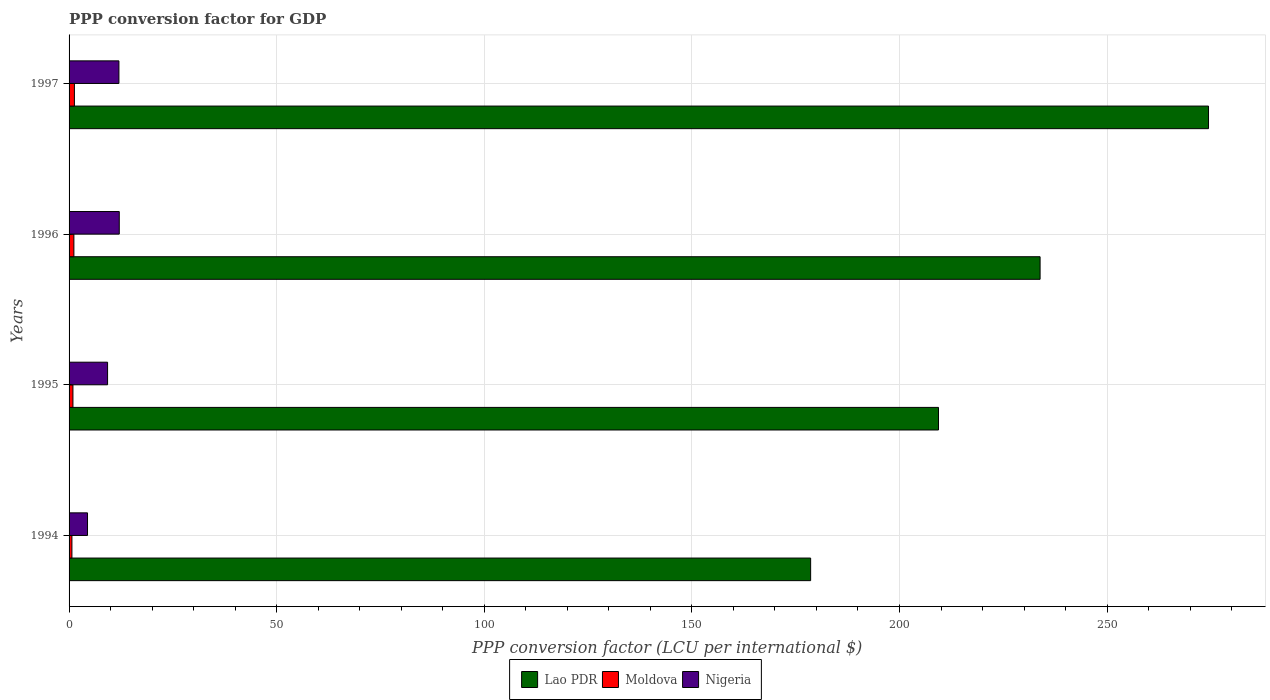How many different coloured bars are there?
Ensure brevity in your answer.  3. How many groups of bars are there?
Offer a terse response. 4. How many bars are there on the 2nd tick from the bottom?
Give a very brief answer. 3. What is the PPP conversion factor for GDP in Nigeria in 1994?
Ensure brevity in your answer.  4.44. Across all years, what is the maximum PPP conversion factor for GDP in Moldova?
Ensure brevity in your answer.  1.28. Across all years, what is the minimum PPP conversion factor for GDP in Lao PDR?
Provide a succinct answer. 178.6. In which year was the PPP conversion factor for GDP in Lao PDR maximum?
Offer a terse response. 1997. What is the total PPP conversion factor for GDP in Moldova in the graph?
Ensure brevity in your answer.  4.06. What is the difference between the PPP conversion factor for GDP in Moldova in 1994 and that in 1995?
Keep it short and to the point. -0.25. What is the difference between the PPP conversion factor for GDP in Nigeria in 1994 and the PPP conversion factor for GDP in Lao PDR in 1995?
Make the answer very short. -204.95. What is the average PPP conversion factor for GDP in Lao PDR per year?
Provide a succinct answer. 224.07. In the year 1994, what is the difference between the PPP conversion factor for GDP in Lao PDR and PPP conversion factor for GDP in Moldova?
Your response must be concise. 177.91. What is the ratio of the PPP conversion factor for GDP in Lao PDR in 1995 to that in 1997?
Your answer should be compact. 0.76. Is the PPP conversion factor for GDP in Nigeria in 1994 less than that in 1997?
Ensure brevity in your answer.  Yes. Is the difference between the PPP conversion factor for GDP in Lao PDR in 1996 and 1997 greater than the difference between the PPP conversion factor for GDP in Moldova in 1996 and 1997?
Make the answer very short. No. What is the difference between the highest and the second highest PPP conversion factor for GDP in Moldova?
Offer a terse response. 0.12. What is the difference between the highest and the lowest PPP conversion factor for GDP in Moldova?
Your answer should be compact. 0.6. What does the 2nd bar from the top in 1994 represents?
Keep it short and to the point. Moldova. What does the 2nd bar from the bottom in 1996 represents?
Your response must be concise. Moldova. Are all the bars in the graph horizontal?
Make the answer very short. Yes. What is the difference between two consecutive major ticks on the X-axis?
Ensure brevity in your answer.  50. Does the graph contain grids?
Keep it short and to the point. Yes. How many legend labels are there?
Provide a short and direct response. 3. How are the legend labels stacked?
Offer a very short reply. Horizontal. What is the title of the graph?
Provide a short and direct response. PPP conversion factor for GDP. Does "Palau" appear as one of the legend labels in the graph?
Your answer should be very brief. No. What is the label or title of the X-axis?
Your answer should be compact. PPP conversion factor (LCU per international $). What is the label or title of the Y-axis?
Your response must be concise. Years. What is the PPP conversion factor (LCU per international $) of Lao PDR in 1994?
Your answer should be compact. 178.6. What is the PPP conversion factor (LCU per international $) of Moldova in 1994?
Offer a terse response. 0.69. What is the PPP conversion factor (LCU per international $) in Nigeria in 1994?
Provide a short and direct response. 4.44. What is the PPP conversion factor (LCU per international $) of Lao PDR in 1995?
Provide a short and direct response. 209.39. What is the PPP conversion factor (LCU per international $) in Moldova in 1995?
Offer a terse response. 0.93. What is the PPP conversion factor (LCU per international $) of Nigeria in 1995?
Offer a very short reply. 9.27. What is the PPP conversion factor (LCU per international $) of Lao PDR in 1996?
Keep it short and to the point. 233.86. What is the PPP conversion factor (LCU per international $) in Moldova in 1996?
Keep it short and to the point. 1.16. What is the PPP conversion factor (LCU per international $) in Nigeria in 1996?
Give a very brief answer. 12.09. What is the PPP conversion factor (LCU per international $) in Lao PDR in 1997?
Offer a very short reply. 274.42. What is the PPP conversion factor (LCU per international $) in Moldova in 1997?
Your answer should be compact. 1.28. What is the PPP conversion factor (LCU per international $) of Nigeria in 1997?
Keep it short and to the point. 12.01. Across all years, what is the maximum PPP conversion factor (LCU per international $) of Lao PDR?
Provide a succinct answer. 274.42. Across all years, what is the maximum PPP conversion factor (LCU per international $) in Moldova?
Give a very brief answer. 1.28. Across all years, what is the maximum PPP conversion factor (LCU per international $) in Nigeria?
Provide a succinct answer. 12.09. Across all years, what is the minimum PPP conversion factor (LCU per international $) in Lao PDR?
Your response must be concise. 178.6. Across all years, what is the minimum PPP conversion factor (LCU per international $) in Moldova?
Ensure brevity in your answer.  0.69. Across all years, what is the minimum PPP conversion factor (LCU per international $) in Nigeria?
Offer a very short reply. 4.44. What is the total PPP conversion factor (LCU per international $) of Lao PDR in the graph?
Your answer should be compact. 896.27. What is the total PPP conversion factor (LCU per international $) of Moldova in the graph?
Offer a terse response. 4.06. What is the total PPP conversion factor (LCU per international $) of Nigeria in the graph?
Provide a short and direct response. 37.81. What is the difference between the PPP conversion factor (LCU per international $) in Lao PDR in 1994 and that in 1995?
Provide a short and direct response. -30.79. What is the difference between the PPP conversion factor (LCU per international $) of Moldova in 1994 and that in 1995?
Your answer should be compact. -0.25. What is the difference between the PPP conversion factor (LCU per international $) in Nigeria in 1994 and that in 1995?
Your response must be concise. -4.83. What is the difference between the PPP conversion factor (LCU per international $) of Lao PDR in 1994 and that in 1996?
Provide a succinct answer. -55.26. What is the difference between the PPP conversion factor (LCU per international $) of Moldova in 1994 and that in 1996?
Keep it short and to the point. -0.48. What is the difference between the PPP conversion factor (LCU per international $) of Nigeria in 1994 and that in 1996?
Keep it short and to the point. -7.65. What is the difference between the PPP conversion factor (LCU per international $) in Lao PDR in 1994 and that in 1997?
Give a very brief answer. -95.82. What is the difference between the PPP conversion factor (LCU per international $) of Moldova in 1994 and that in 1997?
Make the answer very short. -0.6. What is the difference between the PPP conversion factor (LCU per international $) of Nigeria in 1994 and that in 1997?
Make the answer very short. -7.56. What is the difference between the PPP conversion factor (LCU per international $) of Lao PDR in 1995 and that in 1996?
Give a very brief answer. -24.47. What is the difference between the PPP conversion factor (LCU per international $) of Moldova in 1995 and that in 1996?
Provide a short and direct response. -0.23. What is the difference between the PPP conversion factor (LCU per international $) in Nigeria in 1995 and that in 1996?
Offer a very short reply. -2.81. What is the difference between the PPP conversion factor (LCU per international $) of Lao PDR in 1995 and that in 1997?
Your response must be concise. -65.03. What is the difference between the PPP conversion factor (LCU per international $) of Moldova in 1995 and that in 1997?
Your answer should be very brief. -0.35. What is the difference between the PPP conversion factor (LCU per international $) of Nigeria in 1995 and that in 1997?
Offer a terse response. -2.73. What is the difference between the PPP conversion factor (LCU per international $) of Lao PDR in 1996 and that in 1997?
Your answer should be compact. -40.56. What is the difference between the PPP conversion factor (LCU per international $) in Moldova in 1996 and that in 1997?
Ensure brevity in your answer.  -0.12. What is the difference between the PPP conversion factor (LCU per international $) of Nigeria in 1996 and that in 1997?
Keep it short and to the point. 0.08. What is the difference between the PPP conversion factor (LCU per international $) in Lao PDR in 1994 and the PPP conversion factor (LCU per international $) in Moldova in 1995?
Provide a short and direct response. 177.67. What is the difference between the PPP conversion factor (LCU per international $) in Lao PDR in 1994 and the PPP conversion factor (LCU per international $) in Nigeria in 1995?
Your response must be concise. 169.33. What is the difference between the PPP conversion factor (LCU per international $) in Moldova in 1994 and the PPP conversion factor (LCU per international $) in Nigeria in 1995?
Ensure brevity in your answer.  -8.59. What is the difference between the PPP conversion factor (LCU per international $) of Lao PDR in 1994 and the PPP conversion factor (LCU per international $) of Moldova in 1996?
Give a very brief answer. 177.44. What is the difference between the PPP conversion factor (LCU per international $) of Lao PDR in 1994 and the PPP conversion factor (LCU per international $) of Nigeria in 1996?
Provide a short and direct response. 166.51. What is the difference between the PPP conversion factor (LCU per international $) of Moldova in 1994 and the PPP conversion factor (LCU per international $) of Nigeria in 1996?
Provide a short and direct response. -11.4. What is the difference between the PPP conversion factor (LCU per international $) of Lao PDR in 1994 and the PPP conversion factor (LCU per international $) of Moldova in 1997?
Ensure brevity in your answer.  177.31. What is the difference between the PPP conversion factor (LCU per international $) in Lao PDR in 1994 and the PPP conversion factor (LCU per international $) in Nigeria in 1997?
Provide a short and direct response. 166.59. What is the difference between the PPP conversion factor (LCU per international $) in Moldova in 1994 and the PPP conversion factor (LCU per international $) in Nigeria in 1997?
Ensure brevity in your answer.  -11.32. What is the difference between the PPP conversion factor (LCU per international $) of Lao PDR in 1995 and the PPP conversion factor (LCU per international $) of Moldova in 1996?
Give a very brief answer. 208.23. What is the difference between the PPP conversion factor (LCU per international $) in Lao PDR in 1995 and the PPP conversion factor (LCU per international $) in Nigeria in 1996?
Your answer should be very brief. 197.3. What is the difference between the PPP conversion factor (LCU per international $) in Moldova in 1995 and the PPP conversion factor (LCU per international $) in Nigeria in 1996?
Your answer should be very brief. -11.16. What is the difference between the PPP conversion factor (LCU per international $) in Lao PDR in 1995 and the PPP conversion factor (LCU per international $) in Moldova in 1997?
Make the answer very short. 208.11. What is the difference between the PPP conversion factor (LCU per international $) of Lao PDR in 1995 and the PPP conversion factor (LCU per international $) of Nigeria in 1997?
Provide a succinct answer. 197.38. What is the difference between the PPP conversion factor (LCU per international $) of Moldova in 1995 and the PPP conversion factor (LCU per international $) of Nigeria in 1997?
Ensure brevity in your answer.  -11.07. What is the difference between the PPP conversion factor (LCU per international $) in Lao PDR in 1996 and the PPP conversion factor (LCU per international $) in Moldova in 1997?
Offer a very short reply. 232.58. What is the difference between the PPP conversion factor (LCU per international $) of Lao PDR in 1996 and the PPP conversion factor (LCU per international $) of Nigeria in 1997?
Offer a terse response. 221.85. What is the difference between the PPP conversion factor (LCU per international $) in Moldova in 1996 and the PPP conversion factor (LCU per international $) in Nigeria in 1997?
Provide a succinct answer. -10.84. What is the average PPP conversion factor (LCU per international $) of Lao PDR per year?
Offer a very short reply. 224.07. What is the average PPP conversion factor (LCU per international $) of Moldova per year?
Make the answer very short. 1.02. What is the average PPP conversion factor (LCU per international $) in Nigeria per year?
Provide a succinct answer. 9.45. In the year 1994, what is the difference between the PPP conversion factor (LCU per international $) of Lao PDR and PPP conversion factor (LCU per international $) of Moldova?
Ensure brevity in your answer.  177.91. In the year 1994, what is the difference between the PPP conversion factor (LCU per international $) in Lao PDR and PPP conversion factor (LCU per international $) in Nigeria?
Ensure brevity in your answer.  174.16. In the year 1994, what is the difference between the PPP conversion factor (LCU per international $) in Moldova and PPP conversion factor (LCU per international $) in Nigeria?
Provide a succinct answer. -3.76. In the year 1995, what is the difference between the PPP conversion factor (LCU per international $) of Lao PDR and PPP conversion factor (LCU per international $) of Moldova?
Provide a succinct answer. 208.46. In the year 1995, what is the difference between the PPP conversion factor (LCU per international $) of Lao PDR and PPP conversion factor (LCU per international $) of Nigeria?
Keep it short and to the point. 200.12. In the year 1995, what is the difference between the PPP conversion factor (LCU per international $) of Moldova and PPP conversion factor (LCU per international $) of Nigeria?
Keep it short and to the point. -8.34. In the year 1996, what is the difference between the PPP conversion factor (LCU per international $) in Lao PDR and PPP conversion factor (LCU per international $) in Moldova?
Provide a short and direct response. 232.7. In the year 1996, what is the difference between the PPP conversion factor (LCU per international $) in Lao PDR and PPP conversion factor (LCU per international $) in Nigeria?
Provide a succinct answer. 221.77. In the year 1996, what is the difference between the PPP conversion factor (LCU per international $) in Moldova and PPP conversion factor (LCU per international $) in Nigeria?
Provide a short and direct response. -10.93. In the year 1997, what is the difference between the PPP conversion factor (LCU per international $) of Lao PDR and PPP conversion factor (LCU per international $) of Moldova?
Your response must be concise. 273.14. In the year 1997, what is the difference between the PPP conversion factor (LCU per international $) in Lao PDR and PPP conversion factor (LCU per international $) in Nigeria?
Your response must be concise. 262.42. In the year 1997, what is the difference between the PPP conversion factor (LCU per international $) in Moldova and PPP conversion factor (LCU per international $) in Nigeria?
Your response must be concise. -10.72. What is the ratio of the PPP conversion factor (LCU per international $) in Lao PDR in 1994 to that in 1995?
Your answer should be compact. 0.85. What is the ratio of the PPP conversion factor (LCU per international $) of Moldova in 1994 to that in 1995?
Your answer should be compact. 0.74. What is the ratio of the PPP conversion factor (LCU per international $) in Nigeria in 1994 to that in 1995?
Make the answer very short. 0.48. What is the ratio of the PPP conversion factor (LCU per international $) of Lao PDR in 1994 to that in 1996?
Your response must be concise. 0.76. What is the ratio of the PPP conversion factor (LCU per international $) of Moldova in 1994 to that in 1996?
Keep it short and to the point. 0.59. What is the ratio of the PPP conversion factor (LCU per international $) of Nigeria in 1994 to that in 1996?
Provide a short and direct response. 0.37. What is the ratio of the PPP conversion factor (LCU per international $) in Lao PDR in 1994 to that in 1997?
Ensure brevity in your answer.  0.65. What is the ratio of the PPP conversion factor (LCU per international $) in Moldova in 1994 to that in 1997?
Give a very brief answer. 0.53. What is the ratio of the PPP conversion factor (LCU per international $) in Nigeria in 1994 to that in 1997?
Your answer should be compact. 0.37. What is the ratio of the PPP conversion factor (LCU per international $) in Lao PDR in 1995 to that in 1996?
Offer a very short reply. 0.9. What is the ratio of the PPP conversion factor (LCU per international $) of Moldova in 1995 to that in 1996?
Offer a terse response. 0.8. What is the ratio of the PPP conversion factor (LCU per international $) of Nigeria in 1995 to that in 1996?
Keep it short and to the point. 0.77. What is the ratio of the PPP conversion factor (LCU per international $) in Lao PDR in 1995 to that in 1997?
Give a very brief answer. 0.76. What is the ratio of the PPP conversion factor (LCU per international $) of Moldova in 1995 to that in 1997?
Provide a succinct answer. 0.72. What is the ratio of the PPP conversion factor (LCU per international $) of Nigeria in 1995 to that in 1997?
Offer a terse response. 0.77. What is the ratio of the PPP conversion factor (LCU per international $) in Lao PDR in 1996 to that in 1997?
Offer a terse response. 0.85. What is the ratio of the PPP conversion factor (LCU per international $) of Moldova in 1996 to that in 1997?
Offer a very short reply. 0.9. What is the ratio of the PPP conversion factor (LCU per international $) in Nigeria in 1996 to that in 1997?
Your answer should be compact. 1.01. What is the difference between the highest and the second highest PPP conversion factor (LCU per international $) in Lao PDR?
Offer a terse response. 40.56. What is the difference between the highest and the second highest PPP conversion factor (LCU per international $) of Moldova?
Keep it short and to the point. 0.12. What is the difference between the highest and the second highest PPP conversion factor (LCU per international $) of Nigeria?
Your answer should be very brief. 0.08. What is the difference between the highest and the lowest PPP conversion factor (LCU per international $) in Lao PDR?
Your response must be concise. 95.82. What is the difference between the highest and the lowest PPP conversion factor (LCU per international $) in Moldova?
Your response must be concise. 0.6. What is the difference between the highest and the lowest PPP conversion factor (LCU per international $) in Nigeria?
Give a very brief answer. 7.65. 